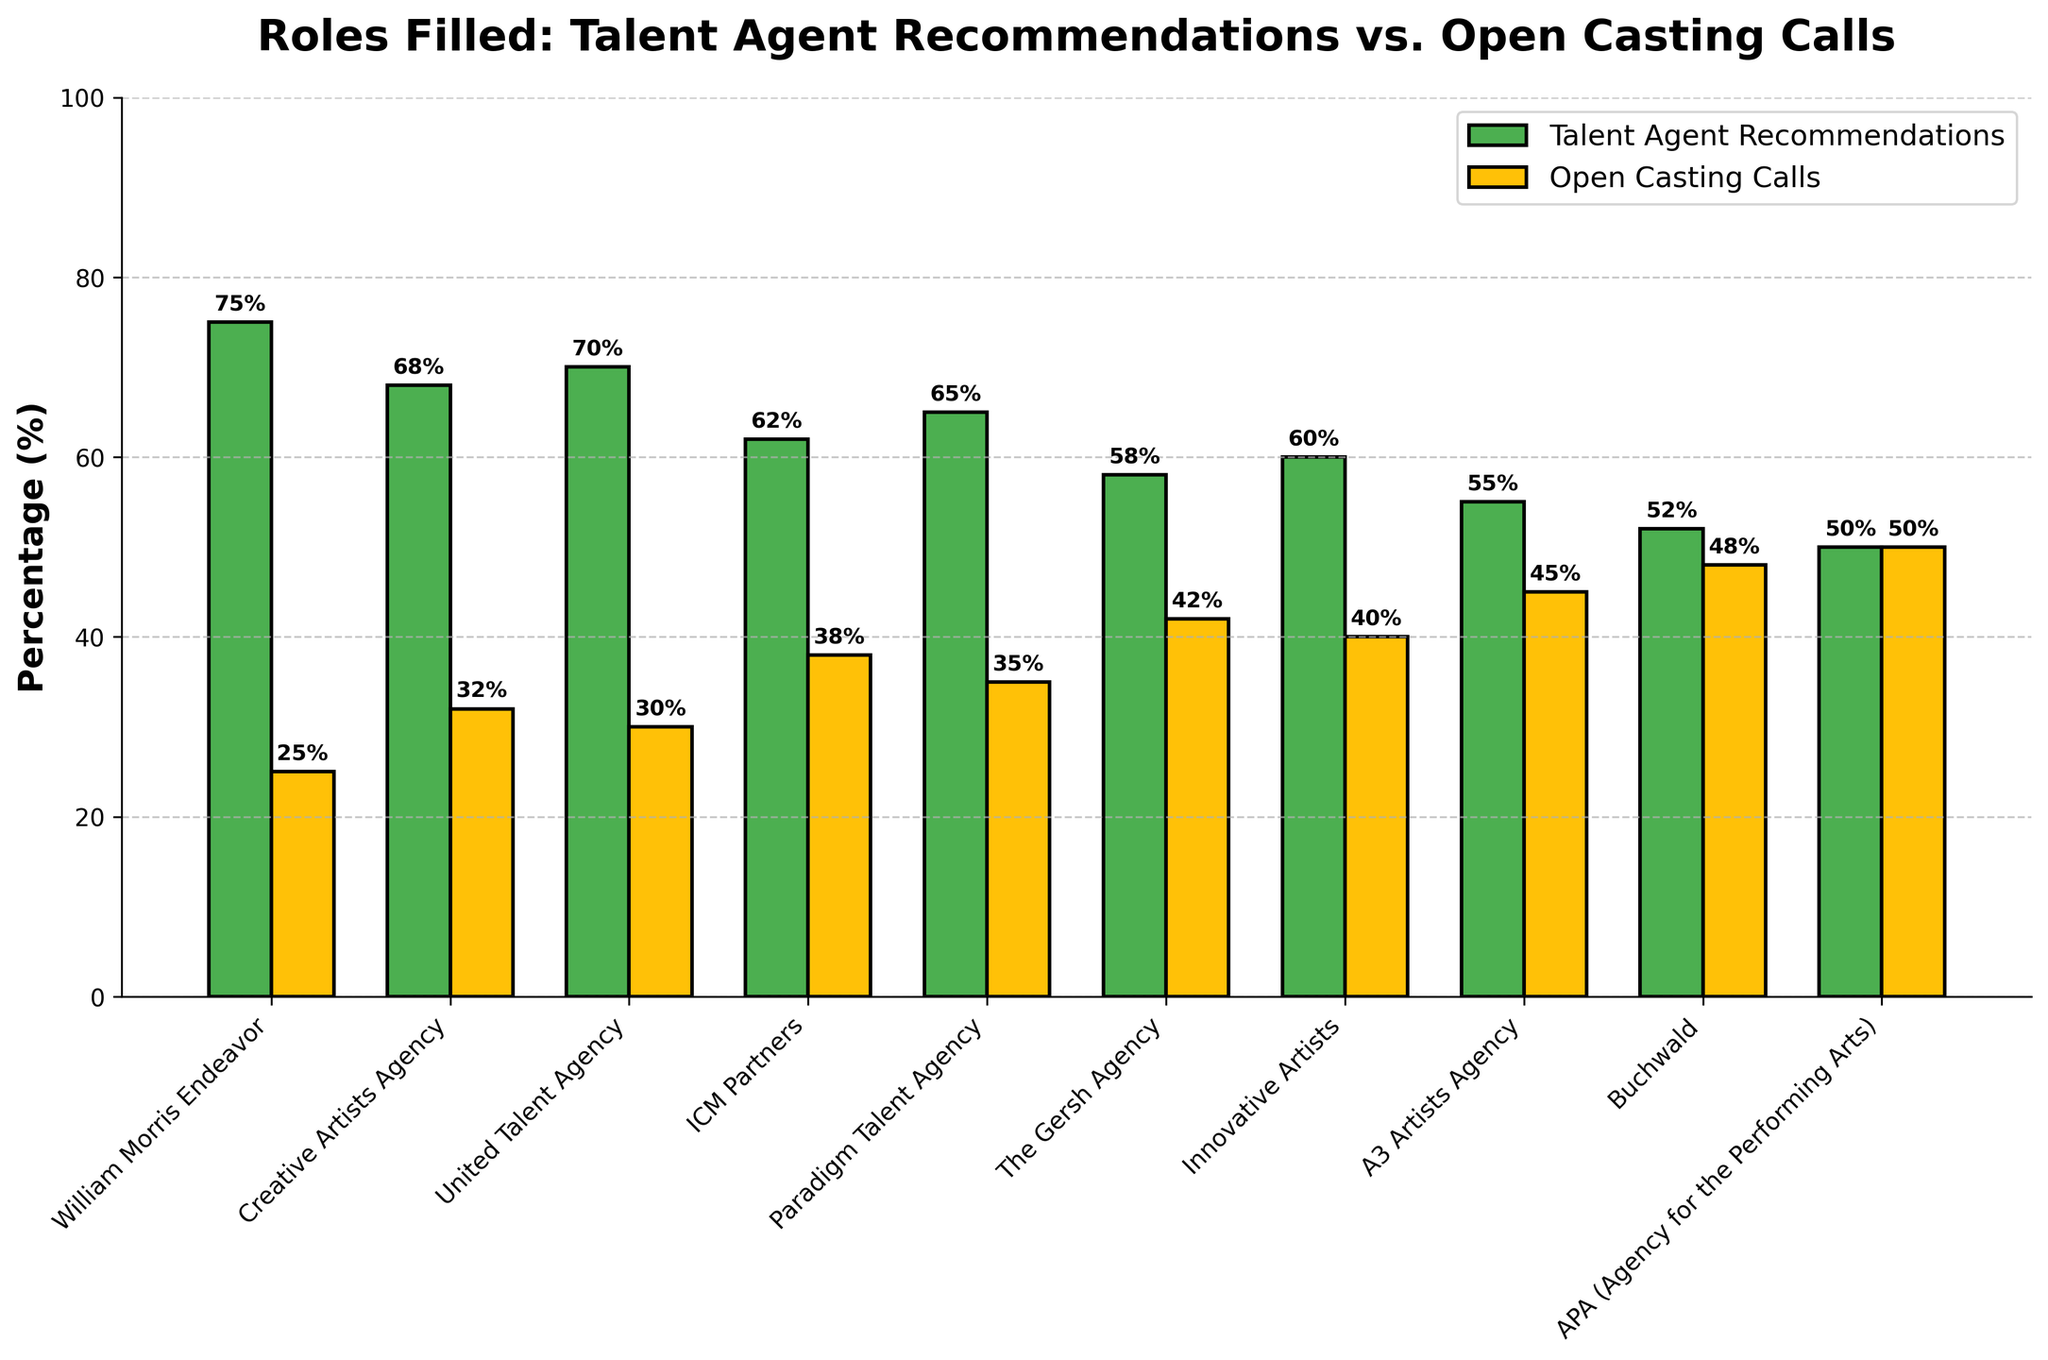What's the agency with the highest percentage of roles filled through talent agent recommendations? To find the agency with the highest percentage of roles filled through talent agent recommendations, look for the tallest green bar. William Morris Endeavor has the highest percentage with 75%.
Answer: William Morris Endeavor Which agencies have an equal percentage of roles filled through talent agent recommendations and open casting calls? Examine the bars for any agency where the green and yellow bars are of equal height. APA (Agency for the Performing Arts) has an equal percentage of 50% each for both methods.
Answer: APA (Agency for the Performing Arts) What is the combined percentage of roles filled through talent agent recommendations for Creative Artists Agency and Paradigm Talent Agency? Add the percentages of talent agent recommendations for both agencies: Creative Artists Agency (68%) and Paradigm Talent Agency (65%). 68 + 65 = 133%.
Answer: 133% Which agency has the smallest difference between the percentages of roles filled through talent agent recommendations and open casting calls? Calculate the difference for each agency and find the smallest one. APA has a difference of 0% (50%-50%), which is the smallest.
Answer: APA (Agency for the Performing Arts) How many agencies have more than 60% of their roles filled through talent agent recommendations? Count the number of agencies with green bars taller than 60%. William Morris Endeavor, Creative Artists Agency, United Talent Agency, Paradigm Talent Agency, and ICM Partners are the ones, making a total of 5.
Answer: 5 Compare The Gersh Agency and Innovative Artists in terms of the percentage of roles filled through open casting calls. Which one has a higher percentage? Look at the height of the yellow bars for both agencies. The Gersh Agency has 42%, and Innovative Artists has 40%. The Gersh Agency has a higher percentage.
Answer: The Gersh Agency What's the average percentage of roles filled through open casting calls for the first three agencies? Calculate the average percentage from the first three agencies: (25 + 32 + 30)/3 = 29%.
Answer: 29% Which agency has the largest gap between the percentages of roles filled through talent agent recommendations and open casting calls? Calculate the differences for each agency and find the largest gap. William Morris Endeavor has the largest gap, with a difference of 50% (75%-25%).
Answer: William Morris Endeavor 